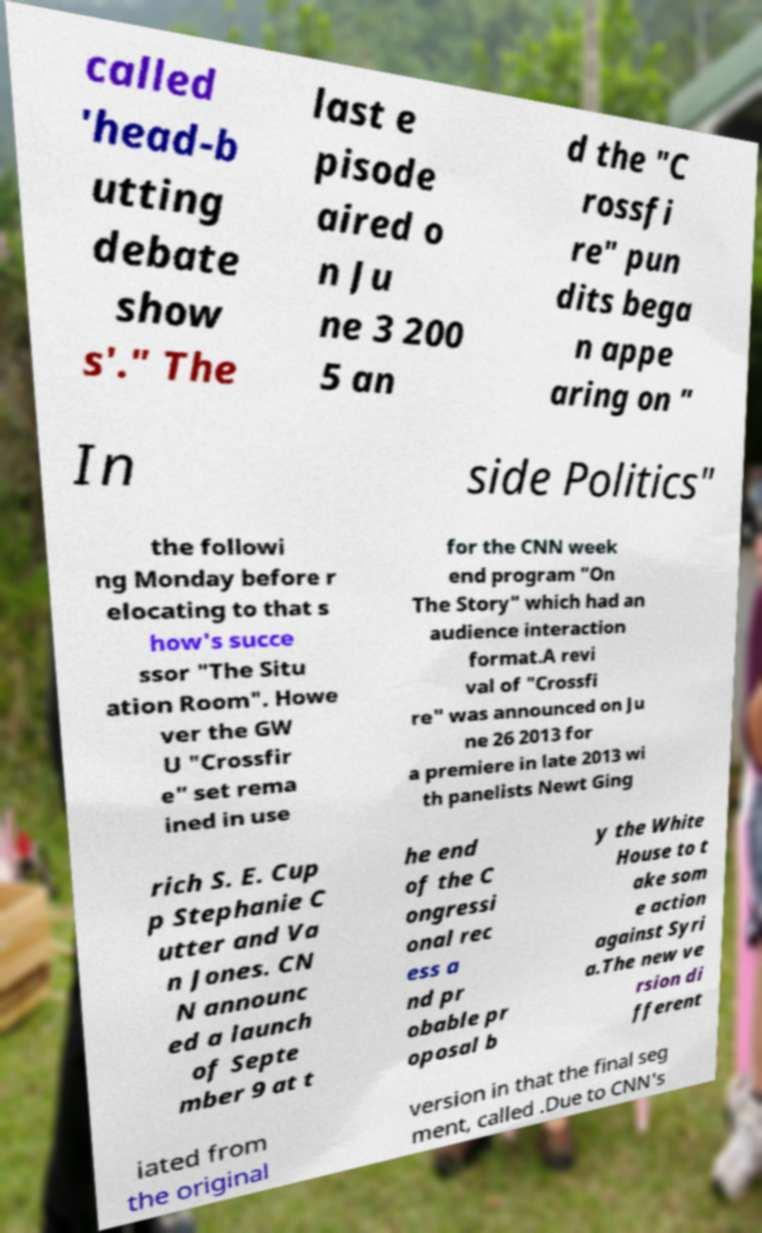Can you accurately transcribe the text from the provided image for me? called 'head-b utting debate show s'." The last e pisode aired o n Ju ne 3 200 5 an d the "C rossfi re" pun dits bega n appe aring on " In side Politics" the followi ng Monday before r elocating to that s how's succe ssor "The Situ ation Room". Howe ver the GW U "Crossfir e" set rema ined in use for the CNN week end program "On The Story" which had an audience interaction format.A revi val of "Crossfi re" was announced on Ju ne 26 2013 for a premiere in late 2013 wi th panelists Newt Ging rich S. E. Cup p Stephanie C utter and Va n Jones. CN N announc ed a launch of Septe mber 9 at t he end of the C ongressi onal rec ess a nd pr obable pr oposal b y the White House to t ake som e action against Syri a.The new ve rsion di fferent iated from the original version in that the final seg ment, called .Due to CNN's 